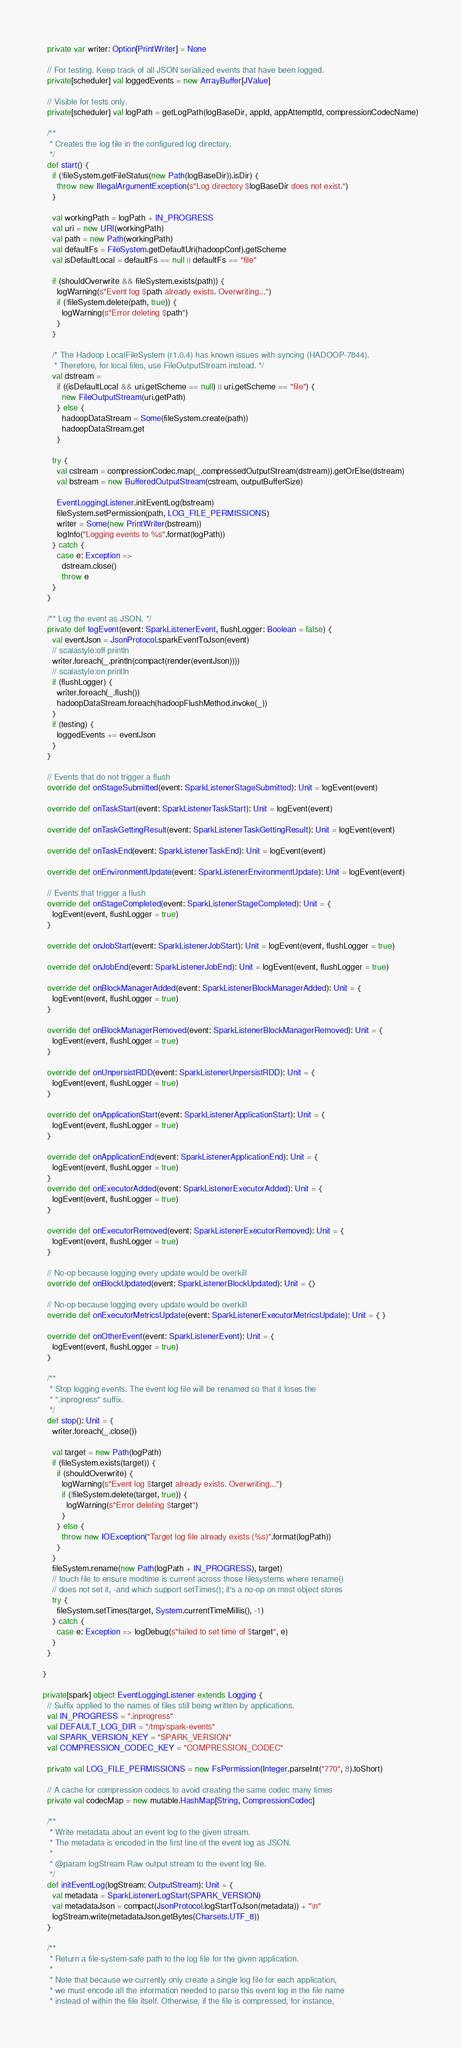<code> <loc_0><loc_0><loc_500><loc_500><_Scala_>  private var writer: Option[PrintWriter] = None

  // For testing. Keep track of all JSON serialized events that have been logged.
  private[scheduler] val loggedEvents = new ArrayBuffer[JValue]

  // Visible for tests only.
  private[scheduler] val logPath = getLogPath(logBaseDir, appId, appAttemptId, compressionCodecName)

  /**
   * Creates the log file in the configured log directory.
   */
  def start() {
    if (!fileSystem.getFileStatus(new Path(logBaseDir)).isDir) {
      throw new IllegalArgumentException(s"Log directory $logBaseDir does not exist.")
    }

    val workingPath = logPath + IN_PROGRESS
    val uri = new URI(workingPath)
    val path = new Path(workingPath)
    val defaultFs = FileSystem.getDefaultUri(hadoopConf).getScheme
    val isDefaultLocal = defaultFs == null || defaultFs == "file"

    if (shouldOverwrite && fileSystem.exists(path)) {
      logWarning(s"Event log $path already exists. Overwriting...")
      if (!fileSystem.delete(path, true)) {
        logWarning(s"Error deleting $path")
      }
    }

    /* The Hadoop LocalFileSystem (r1.0.4) has known issues with syncing (HADOOP-7844).
     * Therefore, for local files, use FileOutputStream instead. */
    val dstream =
      if ((isDefaultLocal && uri.getScheme == null) || uri.getScheme == "file") {
        new FileOutputStream(uri.getPath)
      } else {
        hadoopDataStream = Some(fileSystem.create(path))
        hadoopDataStream.get
      }

    try {
      val cstream = compressionCodec.map(_.compressedOutputStream(dstream)).getOrElse(dstream)
      val bstream = new BufferedOutputStream(cstream, outputBufferSize)

      EventLoggingListener.initEventLog(bstream)
      fileSystem.setPermission(path, LOG_FILE_PERMISSIONS)
      writer = Some(new PrintWriter(bstream))
      logInfo("Logging events to %s".format(logPath))
    } catch {
      case e: Exception =>
        dstream.close()
        throw e
    }
  }

  /** Log the event as JSON. */
  private def logEvent(event: SparkListenerEvent, flushLogger: Boolean = false) {
    val eventJson = JsonProtocol.sparkEventToJson(event)
    // scalastyle:off println
    writer.foreach(_.println(compact(render(eventJson))))
    // scalastyle:on println
    if (flushLogger) {
      writer.foreach(_.flush())
      hadoopDataStream.foreach(hadoopFlushMethod.invoke(_))
    }
    if (testing) {
      loggedEvents += eventJson
    }
  }

  // Events that do not trigger a flush
  override def onStageSubmitted(event: SparkListenerStageSubmitted): Unit = logEvent(event)

  override def onTaskStart(event: SparkListenerTaskStart): Unit = logEvent(event)

  override def onTaskGettingResult(event: SparkListenerTaskGettingResult): Unit = logEvent(event)

  override def onTaskEnd(event: SparkListenerTaskEnd): Unit = logEvent(event)

  override def onEnvironmentUpdate(event: SparkListenerEnvironmentUpdate): Unit = logEvent(event)

  // Events that trigger a flush
  override def onStageCompleted(event: SparkListenerStageCompleted): Unit = {
    logEvent(event, flushLogger = true)
  }

  override def onJobStart(event: SparkListenerJobStart): Unit = logEvent(event, flushLogger = true)

  override def onJobEnd(event: SparkListenerJobEnd): Unit = logEvent(event, flushLogger = true)

  override def onBlockManagerAdded(event: SparkListenerBlockManagerAdded): Unit = {
    logEvent(event, flushLogger = true)
  }

  override def onBlockManagerRemoved(event: SparkListenerBlockManagerRemoved): Unit = {
    logEvent(event, flushLogger = true)
  }

  override def onUnpersistRDD(event: SparkListenerUnpersistRDD): Unit = {
    logEvent(event, flushLogger = true)
  }

  override def onApplicationStart(event: SparkListenerApplicationStart): Unit = {
    logEvent(event, flushLogger = true)
  }

  override def onApplicationEnd(event: SparkListenerApplicationEnd): Unit = {
    logEvent(event, flushLogger = true)
  }
  override def onExecutorAdded(event: SparkListenerExecutorAdded): Unit = {
    logEvent(event, flushLogger = true)
  }

  override def onExecutorRemoved(event: SparkListenerExecutorRemoved): Unit = {
    logEvent(event, flushLogger = true)
  }

  // No-op because logging every update would be overkill
  override def onBlockUpdated(event: SparkListenerBlockUpdated): Unit = {}

  // No-op because logging every update would be overkill
  override def onExecutorMetricsUpdate(event: SparkListenerExecutorMetricsUpdate): Unit = { }

  override def onOtherEvent(event: SparkListenerEvent): Unit = {
    logEvent(event, flushLogger = true)
  }

  /**
   * Stop logging events. The event log file will be renamed so that it loses the
   * ".inprogress" suffix.
   */
  def stop(): Unit = {
    writer.foreach(_.close())

    val target = new Path(logPath)
    if (fileSystem.exists(target)) {
      if (shouldOverwrite) {
        logWarning(s"Event log $target already exists. Overwriting...")
        if (!fileSystem.delete(target, true)) {
          logWarning(s"Error deleting $target")
        }
      } else {
        throw new IOException("Target log file already exists (%s)".format(logPath))
      }
    }
    fileSystem.rename(new Path(logPath + IN_PROGRESS), target)
    // touch file to ensure modtime is current across those filesystems where rename()
    // does not set it, -and which support setTimes(); it's a no-op on most object stores
    try {
      fileSystem.setTimes(target, System.currentTimeMillis(), -1)
    } catch {
      case e: Exception => logDebug(s"failed to set time of $target", e)
    }
  }

}

private[spark] object EventLoggingListener extends Logging {
  // Suffix applied to the names of files still being written by applications.
  val IN_PROGRESS = ".inprogress"
  val DEFAULT_LOG_DIR = "/tmp/spark-events"
  val SPARK_VERSION_KEY = "SPARK_VERSION"
  val COMPRESSION_CODEC_KEY = "COMPRESSION_CODEC"

  private val LOG_FILE_PERMISSIONS = new FsPermission(Integer.parseInt("770", 8).toShort)

  // A cache for compression codecs to avoid creating the same codec many times
  private val codecMap = new mutable.HashMap[String, CompressionCodec]

  /**
   * Write metadata about an event log to the given stream.
   * The metadata is encoded in the first line of the event log as JSON.
   *
   * @param logStream Raw output stream to the event log file.
   */
  def initEventLog(logStream: OutputStream): Unit = {
    val metadata = SparkListenerLogStart(SPARK_VERSION)
    val metadataJson = compact(JsonProtocol.logStartToJson(metadata)) + "\n"
    logStream.write(metadataJson.getBytes(Charsets.UTF_8))
  }

  /**
   * Return a file-system-safe path to the log file for the given application.
   *
   * Note that because we currently only create a single log file for each application,
   * we must encode all the information needed to parse this event log in the file name
   * instead of within the file itself. Otherwise, if the file is compressed, for instance,</code> 